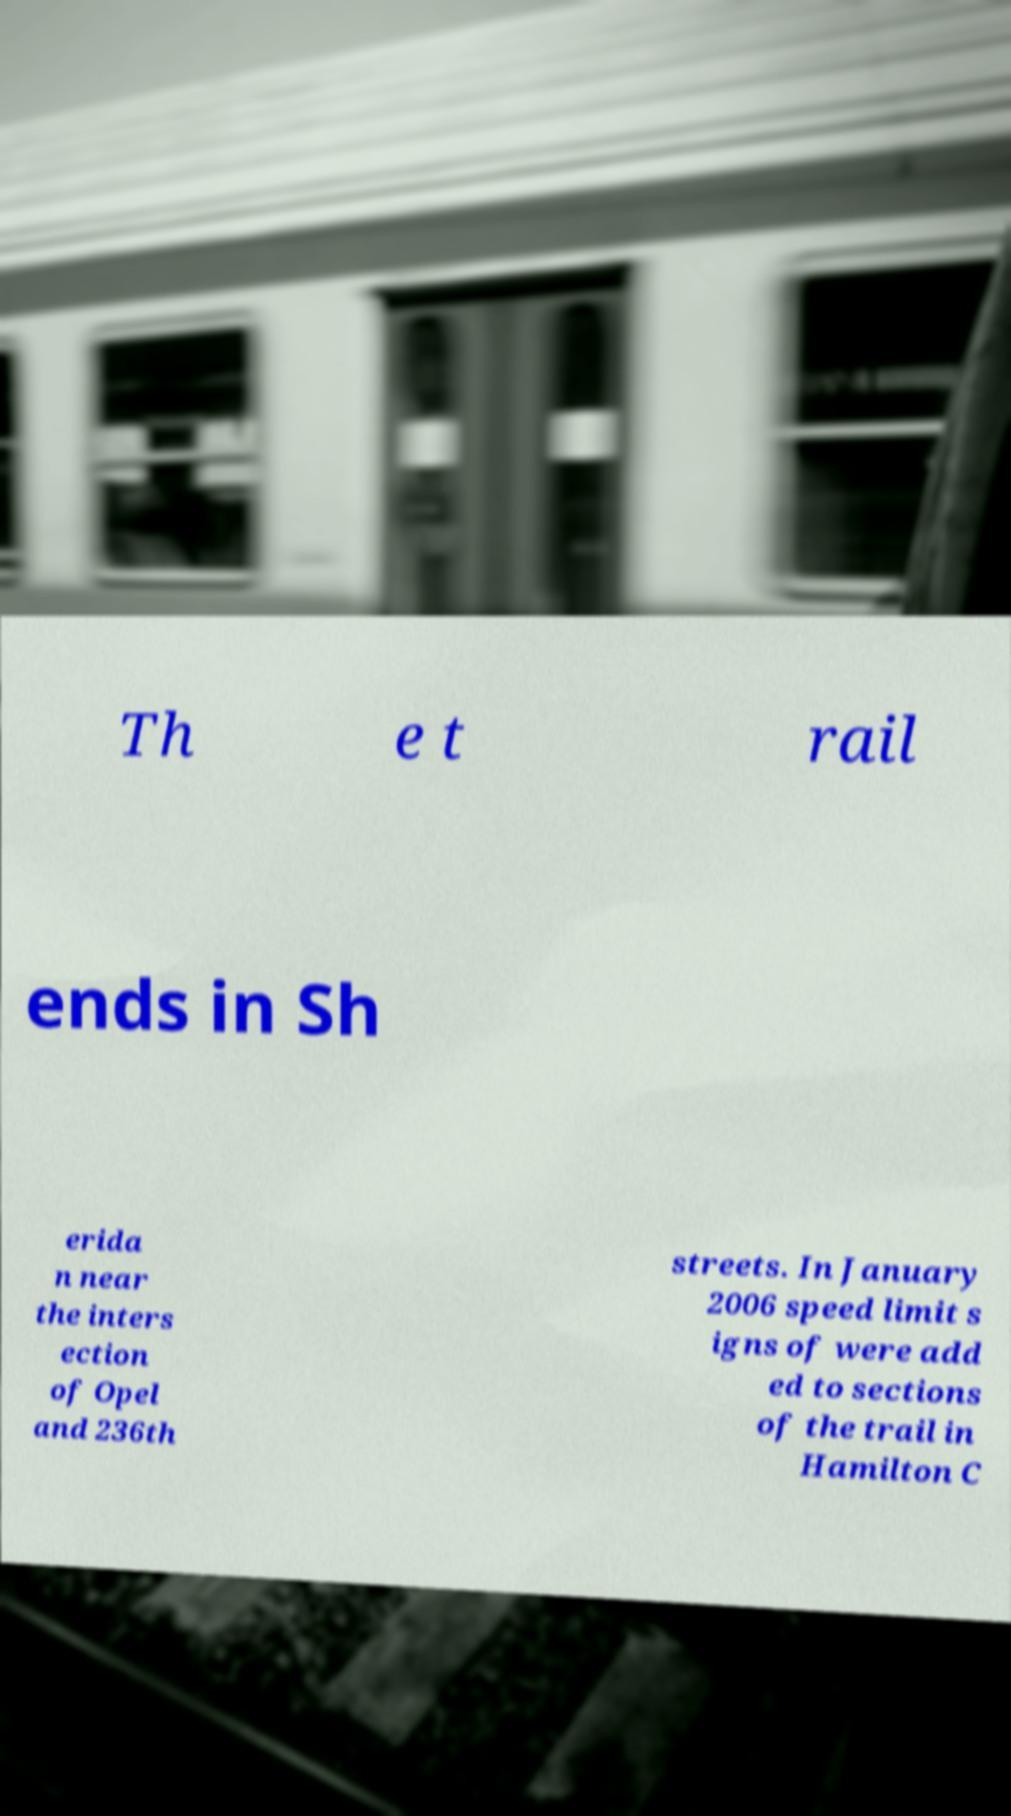Can you read and provide the text displayed in the image?This photo seems to have some interesting text. Can you extract and type it out for me? Th e t rail ends in Sh erida n near the inters ection of Opel and 236th streets. In January 2006 speed limit s igns of were add ed to sections of the trail in Hamilton C 